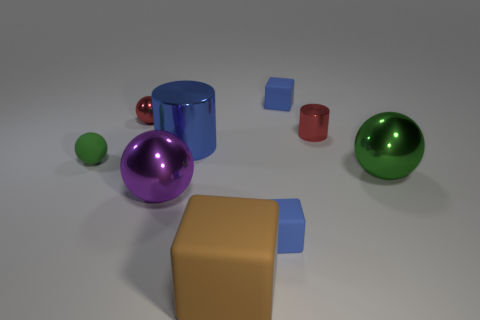Add 1 purple matte cylinders. How many objects exist? 10 Subtract all balls. How many objects are left? 5 Add 5 purple blocks. How many purple blocks exist? 5 Subtract 0 gray spheres. How many objects are left? 9 Subtract all tiny blue things. Subtract all brown things. How many objects are left? 6 Add 7 red objects. How many red objects are left? 9 